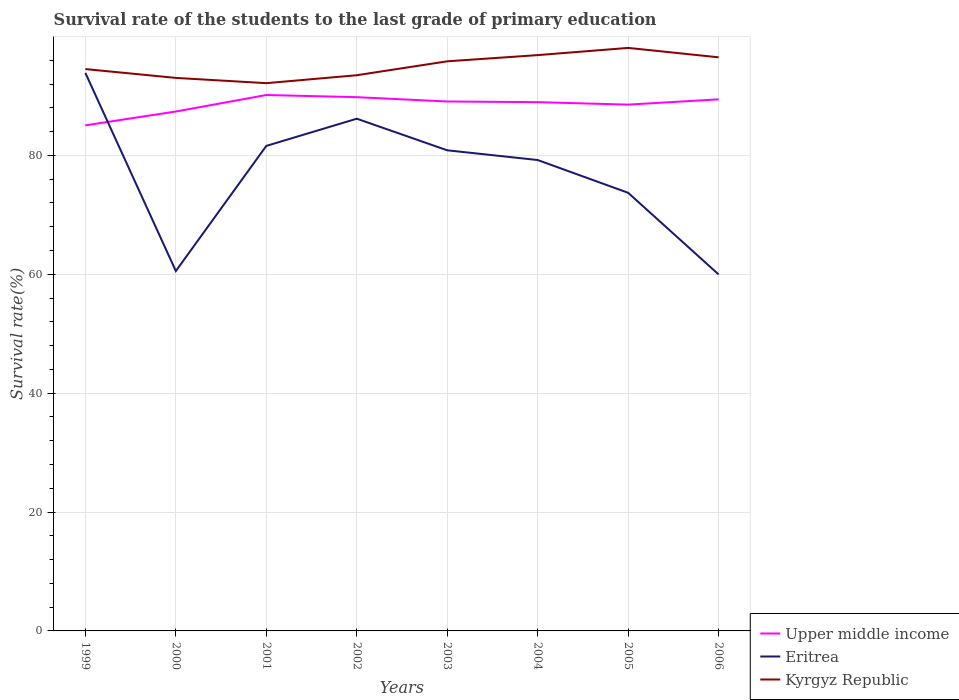How many different coloured lines are there?
Provide a short and direct response. 3. Does the line corresponding to Kyrgyz Republic intersect with the line corresponding to Eritrea?
Give a very brief answer. No. Across all years, what is the maximum survival rate of the students in Upper middle income?
Make the answer very short. 85.05. What is the total survival rate of the students in Upper middle income in the graph?
Keep it short and to the point. -2.78. What is the difference between the highest and the second highest survival rate of the students in Upper middle income?
Your answer should be compact. 5.1. What is the difference between the highest and the lowest survival rate of the students in Eritrea?
Make the answer very short. 5. How many lines are there?
Make the answer very short. 3. Does the graph contain grids?
Keep it short and to the point. Yes. Where does the legend appear in the graph?
Your response must be concise. Bottom right. What is the title of the graph?
Offer a very short reply. Survival rate of the students to the last grade of primary education. Does "China" appear as one of the legend labels in the graph?
Keep it short and to the point. No. What is the label or title of the X-axis?
Your response must be concise. Years. What is the label or title of the Y-axis?
Offer a terse response. Survival rate(%). What is the Survival rate(%) in Upper middle income in 1999?
Make the answer very short. 85.05. What is the Survival rate(%) of Eritrea in 1999?
Offer a terse response. 93.87. What is the Survival rate(%) in Kyrgyz Republic in 1999?
Keep it short and to the point. 94.52. What is the Survival rate(%) of Upper middle income in 2000?
Offer a very short reply. 87.38. What is the Survival rate(%) in Eritrea in 2000?
Keep it short and to the point. 60.54. What is the Survival rate(%) in Kyrgyz Republic in 2000?
Offer a terse response. 93.03. What is the Survival rate(%) of Upper middle income in 2001?
Your response must be concise. 90.16. What is the Survival rate(%) in Eritrea in 2001?
Provide a short and direct response. 81.59. What is the Survival rate(%) in Kyrgyz Republic in 2001?
Provide a succinct answer. 92.15. What is the Survival rate(%) in Upper middle income in 2002?
Offer a terse response. 89.79. What is the Survival rate(%) of Eritrea in 2002?
Your answer should be compact. 86.17. What is the Survival rate(%) of Kyrgyz Republic in 2002?
Offer a terse response. 93.48. What is the Survival rate(%) of Upper middle income in 2003?
Make the answer very short. 89.07. What is the Survival rate(%) of Eritrea in 2003?
Your answer should be very brief. 80.85. What is the Survival rate(%) in Kyrgyz Republic in 2003?
Offer a very short reply. 95.82. What is the Survival rate(%) of Upper middle income in 2004?
Your answer should be very brief. 88.95. What is the Survival rate(%) of Eritrea in 2004?
Provide a short and direct response. 79.22. What is the Survival rate(%) in Kyrgyz Republic in 2004?
Make the answer very short. 96.87. What is the Survival rate(%) of Upper middle income in 2005?
Keep it short and to the point. 88.54. What is the Survival rate(%) of Eritrea in 2005?
Keep it short and to the point. 73.7. What is the Survival rate(%) in Kyrgyz Republic in 2005?
Provide a short and direct response. 98.08. What is the Survival rate(%) of Upper middle income in 2006?
Your response must be concise. 89.43. What is the Survival rate(%) in Eritrea in 2006?
Provide a succinct answer. 59.97. What is the Survival rate(%) in Kyrgyz Republic in 2006?
Your response must be concise. 96.5. Across all years, what is the maximum Survival rate(%) of Upper middle income?
Provide a short and direct response. 90.16. Across all years, what is the maximum Survival rate(%) of Eritrea?
Make the answer very short. 93.87. Across all years, what is the maximum Survival rate(%) of Kyrgyz Republic?
Keep it short and to the point. 98.08. Across all years, what is the minimum Survival rate(%) of Upper middle income?
Make the answer very short. 85.05. Across all years, what is the minimum Survival rate(%) of Eritrea?
Offer a terse response. 59.97. Across all years, what is the minimum Survival rate(%) of Kyrgyz Republic?
Keep it short and to the point. 92.15. What is the total Survival rate(%) of Upper middle income in the graph?
Keep it short and to the point. 708.37. What is the total Survival rate(%) of Eritrea in the graph?
Make the answer very short. 615.93. What is the total Survival rate(%) of Kyrgyz Republic in the graph?
Keep it short and to the point. 760.45. What is the difference between the Survival rate(%) in Upper middle income in 1999 and that in 2000?
Offer a very short reply. -2.33. What is the difference between the Survival rate(%) of Eritrea in 1999 and that in 2000?
Your answer should be compact. 33.33. What is the difference between the Survival rate(%) in Kyrgyz Republic in 1999 and that in 2000?
Make the answer very short. 1.48. What is the difference between the Survival rate(%) of Upper middle income in 1999 and that in 2001?
Offer a terse response. -5.1. What is the difference between the Survival rate(%) in Eritrea in 1999 and that in 2001?
Your response must be concise. 12.28. What is the difference between the Survival rate(%) in Kyrgyz Republic in 1999 and that in 2001?
Offer a terse response. 2.37. What is the difference between the Survival rate(%) in Upper middle income in 1999 and that in 2002?
Give a very brief answer. -4.74. What is the difference between the Survival rate(%) of Eritrea in 1999 and that in 2002?
Offer a terse response. 7.7. What is the difference between the Survival rate(%) in Kyrgyz Republic in 1999 and that in 2002?
Provide a short and direct response. 1.03. What is the difference between the Survival rate(%) in Upper middle income in 1999 and that in 2003?
Your answer should be compact. -4.01. What is the difference between the Survival rate(%) in Eritrea in 1999 and that in 2003?
Your answer should be compact. 13.02. What is the difference between the Survival rate(%) in Kyrgyz Republic in 1999 and that in 2003?
Keep it short and to the point. -1.31. What is the difference between the Survival rate(%) in Upper middle income in 1999 and that in 2004?
Your answer should be very brief. -3.9. What is the difference between the Survival rate(%) in Eritrea in 1999 and that in 2004?
Provide a succinct answer. 14.66. What is the difference between the Survival rate(%) in Kyrgyz Republic in 1999 and that in 2004?
Your response must be concise. -2.35. What is the difference between the Survival rate(%) of Upper middle income in 1999 and that in 2005?
Give a very brief answer. -3.49. What is the difference between the Survival rate(%) of Eritrea in 1999 and that in 2005?
Your answer should be very brief. 20.17. What is the difference between the Survival rate(%) of Kyrgyz Republic in 1999 and that in 2005?
Keep it short and to the point. -3.56. What is the difference between the Survival rate(%) in Upper middle income in 1999 and that in 2006?
Provide a succinct answer. -4.37. What is the difference between the Survival rate(%) of Eritrea in 1999 and that in 2006?
Provide a short and direct response. 33.9. What is the difference between the Survival rate(%) in Kyrgyz Republic in 1999 and that in 2006?
Give a very brief answer. -1.98. What is the difference between the Survival rate(%) in Upper middle income in 2000 and that in 2001?
Your response must be concise. -2.78. What is the difference between the Survival rate(%) in Eritrea in 2000 and that in 2001?
Your answer should be compact. -21.05. What is the difference between the Survival rate(%) in Kyrgyz Republic in 2000 and that in 2001?
Your answer should be compact. 0.89. What is the difference between the Survival rate(%) of Upper middle income in 2000 and that in 2002?
Keep it short and to the point. -2.41. What is the difference between the Survival rate(%) in Eritrea in 2000 and that in 2002?
Your answer should be very brief. -25.63. What is the difference between the Survival rate(%) of Kyrgyz Republic in 2000 and that in 2002?
Your answer should be very brief. -0.45. What is the difference between the Survival rate(%) of Upper middle income in 2000 and that in 2003?
Make the answer very short. -1.69. What is the difference between the Survival rate(%) of Eritrea in 2000 and that in 2003?
Give a very brief answer. -20.31. What is the difference between the Survival rate(%) of Kyrgyz Republic in 2000 and that in 2003?
Offer a terse response. -2.79. What is the difference between the Survival rate(%) in Upper middle income in 2000 and that in 2004?
Offer a very short reply. -1.57. What is the difference between the Survival rate(%) in Eritrea in 2000 and that in 2004?
Provide a short and direct response. -18.67. What is the difference between the Survival rate(%) of Kyrgyz Republic in 2000 and that in 2004?
Keep it short and to the point. -3.83. What is the difference between the Survival rate(%) of Upper middle income in 2000 and that in 2005?
Offer a terse response. -1.16. What is the difference between the Survival rate(%) of Eritrea in 2000 and that in 2005?
Make the answer very short. -13.16. What is the difference between the Survival rate(%) of Kyrgyz Republic in 2000 and that in 2005?
Provide a short and direct response. -5.05. What is the difference between the Survival rate(%) of Upper middle income in 2000 and that in 2006?
Keep it short and to the point. -2.05. What is the difference between the Survival rate(%) in Eritrea in 2000 and that in 2006?
Keep it short and to the point. 0.57. What is the difference between the Survival rate(%) in Kyrgyz Republic in 2000 and that in 2006?
Give a very brief answer. -3.46. What is the difference between the Survival rate(%) in Upper middle income in 2001 and that in 2002?
Ensure brevity in your answer.  0.36. What is the difference between the Survival rate(%) of Eritrea in 2001 and that in 2002?
Offer a very short reply. -4.58. What is the difference between the Survival rate(%) in Kyrgyz Republic in 2001 and that in 2002?
Your response must be concise. -1.34. What is the difference between the Survival rate(%) in Upper middle income in 2001 and that in 2003?
Offer a very short reply. 1.09. What is the difference between the Survival rate(%) in Eritrea in 2001 and that in 2003?
Ensure brevity in your answer.  0.74. What is the difference between the Survival rate(%) in Kyrgyz Republic in 2001 and that in 2003?
Ensure brevity in your answer.  -3.68. What is the difference between the Survival rate(%) in Upper middle income in 2001 and that in 2004?
Ensure brevity in your answer.  1.2. What is the difference between the Survival rate(%) of Eritrea in 2001 and that in 2004?
Provide a succinct answer. 2.38. What is the difference between the Survival rate(%) in Kyrgyz Republic in 2001 and that in 2004?
Make the answer very short. -4.72. What is the difference between the Survival rate(%) of Upper middle income in 2001 and that in 2005?
Offer a very short reply. 1.62. What is the difference between the Survival rate(%) of Eritrea in 2001 and that in 2005?
Make the answer very short. 7.89. What is the difference between the Survival rate(%) of Kyrgyz Republic in 2001 and that in 2005?
Provide a succinct answer. -5.93. What is the difference between the Survival rate(%) of Upper middle income in 2001 and that in 2006?
Provide a succinct answer. 0.73. What is the difference between the Survival rate(%) in Eritrea in 2001 and that in 2006?
Your answer should be very brief. 21.62. What is the difference between the Survival rate(%) of Kyrgyz Republic in 2001 and that in 2006?
Offer a very short reply. -4.35. What is the difference between the Survival rate(%) of Upper middle income in 2002 and that in 2003?
Provide a succinct answer. 0.73. What is the difference between the Survival rate(%) of Eritrea in 2002 and that in 2003?
Ensure brevity in your answer.  5.32. What is the difference between the Survival rate(%) in Kyrgyz Republic in 2002 and that in 2003?
Your answer should be very brief. -2.34. What is the difference between the Survival rate(%) of Upper middle income in 2002 and that in 2004?
Your answer should be very brief. 0.84. What is the difference between the Survival rate(%) in Eritrea in 2002 and that in 2004?
Provide a succinct answer. 6.95. What is the difference between the Survival rate(%) of Kyrgyz Republic in 2002 and that in 2004?
Ensure brevity in your answer.  -3.38. What is the difference between the Survival rate(%) of Upper middle income in 2002 and that in 2005?
Provide a short and direct response. 1.25. What is the difference between the Survival rate(%) in Eritrea in 2002 and that in 2005?
Make the answer very short. 12.47. What is the difference between the Survival rate(%) in Kyrgyz Republic in 2002 and that in 2005?
Your answer should be very brief. -4.6. What is the difference between the Survival rate(%) in Upper middle income in 2002 and that in 2006?
Your answer should be very brief. 0.37. What is the difference between the Survival rate(%) of Eritrea in 2002 and that in 2006?
Make the answer very short. 26.2. What is the difference between the Survival rate(%) of Kyrgyz Republic in 2002 and that in 2006?
Your answer should be compact. -3.01. What is the difference between the Survival rate(%) of Upper middle income in 2003 and that in 2004?
Your answer should be very brief. 0.11. What is the difference between the Survival rate(%) of Eritrea in 2003 and that in 2004?
Provide a short and direct response. 1.64. What is the difference between the Survival rate(%) of Kyrgyz Republic in 2003 and that in 2004?
Your answer should be compact. -1.04. What is the difference between the Survival rate(%) in Upper middle income in 2003 and that in 2005?
Provide a succinct answer. 0.53. What is the difference between the Survival rate(%) of Eritrea in 2003 and that in 2005?
Your response must be concise. 7.15. What is the difference between the Survival rate(%) of Kyrgyz Republic in 2003 and that in 2005?
Offer a terse response. -2.26. What is the difference between the Survival rate(%) of Upper middle income in 2003 and that in 2006?
Offer a terse response. -0.36. What is the difference between the Survival rate(%) in Eritrea in 2003 and that in 2006?
Give a very brief answer. 20.88. What is the difference between the Survival rate(%) in Kyrgyz Republic in 2003 and that in 2006?
Keep it short and to the point. -0.67. What is the difference between the Survival rate(%) of Upper middle income in 2004 and that in 2005?
Make the answer very short. 0.41. What is the difference between the Survival rate(%) of Eritrea in 2004 and that in 2005?
Provide a succinct answer. 5.51. What is the difference between the Survival rate(%) of Kyrgyz Republic in 2004 and that in 2005?
Offer a terse response. -1.21. What is the difference between the Survival rate(%) of Upper middle income in 2004 and that in 2006?
Give a very brief answer. -0.47. What is the difference between the Survival rate(%) in Eritrea in 2004 and that in 2006?
Keep it short and to the point. 19.25. What is the difference between the Survival rate(%) of Kyrgyz Republic in 2004 and that in 2006?
Offer a terse response. 0.37. What is the difference between the Survival rate(%) of Upper middle income in 2005 and that in 2006?
Provide a short and direct response. -0.89. What is the difference between the Survival rate(%) in Eritrea in 2005 and that in 2006?
Give a very brief answer. 13.73. What is the difference between the Survival rate(%) of Kyrgyz Republic in 2005 and that in 2006?
Ensure brevity in your answer.  1.58. What is the difference between the Survival rate(%) in Upper middle income in 1999 and the Survival rate(%) in Eritrea in 2000?
Offer a terse response. 24.51. What is the difference between the Survival rate(%) of Upper middle income in 1999 and the Survival rate(%) of Kyrgyz Republic in 2000?
Give a very brief answer. -7.98. What is the difference between the Survival rate(%) in Eritrea in 1999 and the Survival rate(%) in Kyrgyz Republic in 2000?
Provide a short and direct response. 0.84. What is the difference between the Survival rate(%) of Upper middle income in 1999 and the Survival rate(%) of Eritrea in 2001?
Make the answer very short. 3.46. What is the difference between the Survival rate(%) of Upper middle income in 1999 and the Survival rate(%) of Kyrgyz Republic in 2001?
Give a very brief answer. -7.1. What is the difference between the Survival rate(%) in Eritrea in 1999 and the Survival rate(%) in Kyrgyz Republic in 2001?
Provide a succinct answer. 1.73. What is the difference between the Survival rate(%) of Upper middle income in 1999 and the Survival rate(%) of Eritrea in 2002?
Provide a short and direct response. -1.12. What is the difference between the Survival rate(%) of Upper middle income in 1999 and the Survival rate(%) of Kyrgyz Republic in 2002?
Provide a succinct answer. -8.43. What is the difference between the Survival rate(%) in Eritrea in 1999 and the Survival rate(%) in Kyrgyz Republic in 2002?
Provide a short and direct response. 0.39. What is the difference between the Survival rate(%) of Upper middle income in 1999 and the Survival rate(%) of Eritrea in 2003?
Offer a very short reply. 4.2. What is the difference between the Survival rate(%) in Upper middle income in 1999 and the Survival rate(%) in Kyrgyz Republic in 2003?
Keep it short and to the point. -10.77. What is the difference between the Survival rate(%) of Eritrea in 1999 and the Survival rate(%) of Kyrgyz Republic in 2003?
Your answer should be very brief. -1.95. What is the difference between the Survival rate(%) of Upper middle income in 1999 and the Survival rate(%) of Eritrea in 2004?
Your answer should be compact. 5.83. What is the difference between the Survival rate(%) in Upper middle income in 1999 and the Survival rate(%) in Kyrgyz Republic in 2004?
Provide a short and direct response. -11.81. What is the difference between the Survival rate(%) of Eritrea in 1999 and the Survival rate(%) of Kyrgyz Republic in 2004?
Ensure brevity in your answer.  -2.99. What is the difference between the Survival rate(%) in Upper middle income in 1999 and the Survival rate(%) in Eritrea in 2005?
Give a very brief answer. 11.35. What is the difference between the Survival rate(%) of Upper middle income in 1999 and the Survival rate(%) of Kyrgyz Republic in 2005?
Keep it short and to the point. -13.03. What is the difference between the Survival rate(%) in Eritrea in 1999 and the Survival rate(%) in Kyrgyz Republic in 2005?
Provide a short and direct response. -4.21. What is the difference between the Survival rate(%) of Upper middle income in 1999 and the Survival rate(%) of Eritrea in 2006?
Give a very brief answer. 25.08. What is the difference between the Survival rate(%) of Upper middle income in 1999 and the Survival rate(%) of Kyrgyz Republic in 2006?
Offer a very short reply. -11.44. What is the difference between the Survival rate(%) of Eritrea in 1999 and the Survival rate(%) of Kyrgyz Republic in 2006?
Your answer should be very brief. -2.62. What is the difference between the Survival rate(%) of Upper middle income in 2000 and the Survival rate(%) of Eritrea in 2001?
Your answer should be compact. 5.79. What is the difference between the Survival rate(%) in Upper middle income in 2000 and the Survival rate(%) in Kyrgyz Republic in 2001?
Your answer should be very brief. -4.77. What is the difference between the Survival rate(%) of Eritrea in 2000 and the Survival rate(%) of Kyrgyz Republic in 2001?
Your answer should be very brief. -31.6. What is the difference between the Survival rate(%) in Upper middle income in 2000 and the Survival rate(%) in Eritrea in 2002?
Your answer should be very brief. 1.21. What is the difference between the Survival rate(%) of Upper middle income in 2000 and the Survival rate(%) of Kyrgyz Republic in 2002?
Give a very brief answer. -6.1. What is the difference between the Survival rate(%) of Eritrea in 2000 and the Survival rate(%) of Kyrgyz Republic in 2002?
Provide a short and direct response. -32.94. What is the difference between the Survival rate(%) of Upper middle income in 2000 and the Survival rate(%) of Eritrea in 2003?
Your answer should be compact. 6.53. What is the difference between the Survival rate(%) in Upper middle income in 2000 and the Survival rate(%) in Kyrgyz Republic in 2003?
Offer a very short reply. -8.45. What is the difference between the Survival rate(%) in Eritrea in 2000 and the Survival rate(%) in Kyrgyz Republic in 2003?
Make the answer very short. -35.28. What is the difference between the Survival rate(%) in Upper middle income in 2000 and the Survival rate(%) in Eritrea in 2004?
Make the answer very short. 8.16. What is the difference between the Survival rate(%) in Upper middle income in 2000 and the Survival rate(%) in Kyrgyz Republic in 2004?
Provide a short and direct response. -9.49. What is the difference between the Survival rate(%) of Eritrea in 2000 and the Survival rate(%) of Kyrgyz Republic in 2004?
Offer a terse response. -36.32. What is the difference between the Survival rate(%) in Upper middle income in 2000 and the Survival rate(%) in Eritrea in 2005?
Give a very brief answer. 13.68. What is the difference between the Survival rate(%) of Upper middle income in 2000 and the Survival rate(%) of Kyrgyz Republic in 2005?
Make the answer very short. -10.7. What is the difference between the Survival rate(%) in Eritrea in 2000 and the Survival rate(%) in Kyrgyz Republic in 2005?
Your answer should be very brief. -37.54. What is the difference between the Survival rate(%) in Upper middle income in 2000 and the Survival rate(%) in Eritrea in 2006?
Offer a very short reply. 27.41. What is the difference between the Survival rate(%) of Upper middle income in 2000 and the Survival rate(%) of Kyrgyz Republic in 2006?
Provide a short and direct response. -9.12. What is the difference between the Survival rate(%) of Eritrea in 2000 and the Survival rate(%) of Kyrgyz Republic in 2006?
Give a very brief answer. -35.95. What is the difference between the Survival rate(%) of Upper middle income in 2001 and the Survival rate(%) of Eritrea in 2002?
Keep it short and to the point. 3.99. What is the difference between the Survival rate(%) in Upper middle income in 2001 and the Survival rate(%) in Kyrgyz Republic in 2002?
Your answer should be compact. -3.33. What is the difference between the Survival rate(%) in Eritrea in 2001 and the Survival rate(%) in Kyrgyz Republic in 2002?
Give a very brief answer. -11.89. What is the difference between the Survival rate(%) in Upper middle income in 2001 and the Survival rate(%) in Eritrea in 2003?
Your answer should be compact. 9.3. What is the difference between the Survival rate(%) of Upper middle income in 2001 and the Survival rate(%) of Kyrgyz Republic in 2003?
Ensure brevity in your answer.  -5.67. What is the difference between the Survival rate(%) in Eritrea in 2001 and the Survival rate(%) in Kyrgyz Republic in 2003?
Ensure brevity in your answer.  -14.23. What is the difference between the Survival rate(%) of Upper middle income in 2001 and the Survival rate(%) of Eritrea in 2004?
Provide a short and direct response. 10.94. What is the difference between the Survival rate(%) of Upper middle income in 2001 and the Survival rate(%) of Kyrgyz Republic in 2004?
Offer a terse response. -6.71. What is the difference between the Survival rate(%) of Eritrea in 2001 and the Survival rate(%) of Kyrgyz Republic in 2004?
Make the answer very short. -15.27. What is the difference between the Survival rate(%) of Upper middle income in 2001 and the Survival rate(%) of Eritrea in 2005?
Your answer should be very brief. 16.45. What is the difference between the Survival rate(%) in Upper middle income in 2001 and the Survival rate(%) in Kyrgyz Republic in 2005?
Your answer should be compact. -7.92. What is the difference between the Survival rate(%) in Eritrea in 2001 and the Survival rate(%) in Kyrgyz Republic in 2005?
Your response must be concise. -16.49. What is the difference between the Survival rate(%) in Upper middle income in 2001 and the Survival rate(%) in Eritrea in 2006?
Your answer should be very brief. 30.19. What is the difference between the Survival rate(%) in Upper middle income in 2001 and the Survival rate(%) in Kyrgyz Republic in 2006?
Provide a short and direct response. -6.34. What is the difference between the Survival rate(%) of Eritrea in 2001 and the Survival rate(%) of Kyrgyz Republic in 2006?
Ensure brevity in your answer.  -14.9. What is the difference between the Survival rate(%) in Upper middle income in 2002 and the Survival rate(%) in Eritrea in 2003?
Offer a very short reply. 8.94. What is the difference between the Survival rate(%) of Upper middle income in 2002 and the Survival rate(%) of Kyrgyz Republic in 2003?
Your answer should be very brief. -6.03. What is the difference between the Survival rate(%) in Eritrea in 2002 and the Survival rate(%) in Kyrgyz Republic in 2003?
Make the answer very short. -9.65. What is the difference between the Survival rate(%) of Upper middle income in 2002 and the Survival rate(%) of Eritrea in 2004?
Your answer should be compact. 10.57. What is the difference between the Survival rate(%) in Upper middle income in 2002 and the Survival rate(%) in Kyrgyz Republic in 2004?
Your answer should be very brief. -7.07. What is the difference between the Survival rate(%) in Eritrea in 2002 and the Survival rate(%) in Kyrgyz Republic in 2004?
Ensure brevity in your answer.  -10.7. What is the difference between the Survival rate(%) of Upper middle income in 2002 and the Survival rate(%) of Eritrea in 2005?
Ensure brevity in your answer.  16.09. What is the difference between the Survival rate(%) of Upper middle income in 2002 and the Survival rate(%) of Kyrgyz Republic in 2005?
Offer a terse response. -8.29. What is the difference between the Survival rate(%) of Eritrea in 2002 and the Survival rate(%) of Kyrgyz Republic in 2005?
Offer a very short reply. -11.91. What is the difference between the Survival rate(%) in Upper middle income in 2002 and the Survival rate(%) in Eritrea in 2006?
Provide a succinct answer. 29.82. What is the difference between the Survival rate(%) of Upper middle income in 2002 and the Survival rate(%) of Kyrgyz Republic in 2006?
Give a very brief answer. -6.7. What is the difference between the Survival rate(%) of Eritrea in 2002 and the Survival rate(%) of Kyrgyz Republic in 2006?
Your answer should be compact. -10.33. What is the difference between the Survival rate(%) of Upper middle income in 2003 and the Survival rate(%) of Eritrea in 2004?
Provide a short and direct response. 9.85. What is the difference between the Survival rate(%) of Upper middle income in 2003 and the Survival rate(%) of Kyrgyz Republic in 2004?
Your response must be concise. -7.8. What is the difference between the Survival rate(%) in Eritrea in 2003 and the Survival rate(%) in Kyrgyz Republic in 2004?
Offer a terse response. -16.01. What is the difference between the Survival rate(%) of Upper middle income in 2003 and the Survival rate(%) of Eritrea in 2005?
Provide a short and direct response. 15.36. What is the difference between the Survival rate(%) in Upper middle income in 2003 and the Survival rate(%) in Kyrgyz Republic in 2005?
Give a very brief answer. -9.01. What is the difference between the Survival rate(%) of Eritrea in 2003 and the Survival rate(%) of Kyrgyz Republic in 2005?
Your answer should be very brief. -17.23. What is the difference between the Survival rate(%) in Upper middle income in 2003 and the Survival rate(%) in Eritrea in 2006?
Offer a very short reply. 29.1. What is the difference between the Survival rate(%) in Upper middle income in 2003 and the Survival rate(%) in Kyrgyz Republic in 2006?
Offer a terse response. -7.43. What is the difference between the Survival rate(%) of Eritrea in 2003 and the Survival rate(%) of Kyrgyz Republic in 2006?
Your answer should be very brief. -15.64. What is the difference between the Survival rate(%) in Upper middle income in 2004 and the Survival rate(%) in Eritrea in 2005?
Keep it short and to the point. 15.25. What is the difference between the Survival rate(%) in Upper middle income in 2004 and the Survival rate(%) in Kyrgyz Republic in 2005?
Offer a very short reply. -9.13. What is the difference between the Survival rate(%) of Eritrea in 2004 and the Survival rate(%) of Kyrgyz Republic in 2005?
Your answer should be very brief. -18.86. What is the difference between the Survival rate(%) in Upper middle income in 2004 and the Survival rate(%) in Eritrea in 2006?
Provide a short and direct response. 28.98. What is the difference between the Survival rate(%) of Upper middle income in 2004 and the Survival rate(%) of Kyrgyz Republic in 2006?
Your response must be concise. -7.54. What is the difference between the Survival rate(%) of Eritrea in 2004 and the Survival rate(%) of Kyrgyz Republic in 2006?
Offer a terse response. -17.28. What is the difference between the Survival rate(%) in Upper middle income in 2005 and the Survival rate(%) in Eritrea in 2006?
Ensure brevity in your answer.  28.57. What is the difference between the Survival rate(%) in Upper middle income in 2005 and the Survival rate(%) in Kyrgyz Republic in 2006?
Give a very brief answer. -7.96. What is the difference between the Survival rate(%) in Eritrea in 2005 and the Survival rate(%) in Kyrgyz Republic in 2006?
Make the answer very short. -22.79. What is the average Survival rate(%) of Upper middle income per year?
Provide a short and direct response. 88.55. What is the average Survival rate(%) in Eritrea per year?
Give a very brief answer. 76.99. What is the average Survival rate(%) of Kyrgyz Republic per year?
Keep it short and to the point. 95.06. In the year 1999, what is the difference between the Survival rate(%) of Upper middle income and Survival rate(%) of Eritrea?
Keep it short and to the point. -8.82. In the year 1999, what is the difference between the Survival rate(%) of Upper middle income and Survival rate(%) of Kyrgyz Republic?
Your answer should be compact. -9.47. In the year 1999, what is the difference between the Survival rate(%) in Eritrea and Survival rate(%) in Kyrgyz Republic?
Ensure brevity in your answer.  -0.64. In the year 2000, what is the difference between the Survival rate(%) in Upper middle income and Survival rate(%) in Eritrea?
Your answer should be compact. 26.84. In the year 2000, what is the difference between the Survival rate(%) of Upper middle income and Survival rate(%) of Kyrgyz Republic?
Ensure brevity in your answer.  -5.65. In the year 2000, what is the difference between the Survival rate(%) in Eritrea and Survival rate(%) in Kyrgyz Republic?
Give a very brief answer. -32.49. In the year 2001, what is the difference between the Survival rate(%) of Upper middle income and Survival rate(%) of Eritrea?
Your answer should be very brief. 8.56. In the year 2001, what is the difference between the Survival rate(%) in Upper middle income and Survival rate(%) in Kyrgyz Republic?
Give a very brief answer. -1.99. In the year 2001, what is the difference between the Survival rate(%) in Eritrea and Survival rate(%) in Kyrgyz Republic?
Provide a succinct answer. -10.55. In the year 2002, what is the difference between the Survival rate(%) of Upper middle income and Survival rate(%) of Eritrea?
Provide a short and direct response. 3.62. In the year 2002, what is the difference between the Survival rate(%) in Upper middle income and Survival rate(%) in Kyrgyz Republic?
Your answer should be very brief. -3.69. In the year 2002, what is the difference between the Survival rate(%) of Eritrea and Survival rate(%) of Kyrgyz Republic?
Offer a very short reply. -7.31. In the year 2003, what is the difference between the Survival rate(%) in Upper middle income and Survival rate(%) in Eritrea?
Provide a succinct answer. 8.21. In the year 2003, what is the difference between the Survival rate(%) in Upper middle income and Survival rate(%) in Kyrgyz Republic?
Provide a short and direct response. -6.76. In the year 2003, what is the difference between the Survival rate(%) of Eritrea and Survival rate(%) of Kyrgyz Republic?
Give a very brief answer. -14.97. In the year 2004, what is the difference between the Survival rate(%) in Upper middle income and Survival rate(%) in Eritrea?
Offer a very short reply. 9.74. In the year 2004, what is the difference between the Survival rate(%) of Upper middle income and Survival rate(%) of Kyrgyz Republic?
Offer a terse response. -7.91. In the year 2004, what is the difference between the Survival rate(%) in Eritrea and Survival rate(%) in Kyrgyz Republic?
Your response must be concise. -17.65. In the year 2005, what is the difference between the Survival rate(%) of Upper middle income and Survival rate(%) of Eritrea?
Offer a very short reply. 14.84. In the year 2005, what is the difference between the Survival rate(%) in Upper middle income and Survival rate(%) in Kyrgyz Republic?
Your response must be concise. -9.54. In the year 2005, what is the difference between the Survival rate(%) of Eritrea and Survival rate(%) of Kyrgyz Republic?
Provide a succinct answer. -24.38. In the year 2006, what is the difference between the Survival rate(%) of Upper middle income and Survival rate(%) of Eritrea?
Provide a short and direct response. 29.46. In the year 2006, what is the difference between the Survival rate(%) of Upper middle income and Survival rate(%) of Kyrgyz Republic?
Your answer should be very brief. -7.07. In the year 2006, what is the difference between the Survival rate(%) of Eritrea and Survival rate(%) of Kyrgyz Republic?
Give a very brief answer. -36.53. What is the ratio of the Survival rate(%) in Upper middle income in 1999 to that in 2000?
Offer a terse response. 0.97. What is the ratio of the Survival rate(%) in Eritrea in 1999 to that in 2000?
Offer a terse response. 1.55. What is the ratio of the Survival rate(%) of Kyrgyz Republic in 1999 to that in 2000?
Make the answer very short. 1.02. What is the ratio of the Survival rate(%) in Upper middle income in 1999 to that in 2001?
Your response must be concise. 0.94. What is the ratio of the Survival rate(%) of Eritrea in 1999 to that in 2001?
Your answer should be very brief. 1.15. What is the ratio of the Survival rate(%) of Kyrgyz Republic in 1999 to that in 2001?
Offer a terse response. 1.03. What is the ratio of the Survival rate(%) in Upper middle income in 1999 to that in 2002?
Offer a very short reply. 0.95. What is the ratio of the Survival rate(%) of Eritrea in 1999 to that in 2002?
Provide a short and direct response. 1.09. What is the ratio of the Survival rate(%) in Kyrgyz Republic in 1999 to that in 2002?
Ensure brevity in your answer.  1.01. What is the ratio of the Survival rate(%) in Upper middle income in 1999 to that in 2003?
Ensure brevity in your answer.  0.95. What is the ratio of the Survival rate(%) of Eritrea in 1999 to that in 2003?
Your answer should be very brief. 1.16. What is the ratio of the Survival rate(%) of Kyrgyz Republic in 1999 to that in 2003?
Offer a terse response. 0.99. What is the ratio of the Survival rate(%) of Upper middle income in 1999 to that in 2004?
Offer a very short reply. 0.96. What is the ratio of the Survival rate(%) in Eritrea in 1999 to that in 2004?
Offer a very short reply. 1.19. What is the ratio of the Survival rate(%) in Kyrgyz Republic in 1999 to that in 2004?
Give a very brief answer. 0.98. What is the ratio of the Survival rate(%) of Upper middle income in 1999 to that in 2005?
Give a very brief answer. 0.96. What is the ratio of the Survival rate(%) in Eritrea in 1999 to that in 2005?
Offer a very short reply. 1.27. What is the ratio of the Survival rate(%) of Kyrgyz Republic in 1999 to that in 2005?
Offer a terse response. 0.96. What is the ratio of the Survival rate(%) of Upper middle income in 1999 to that in 2006?
Your answer should be compact. 0.95. What is the ratio of the Survival rate(%) of Eritrea in 1999 to that in 2006?
Your answer should be compact. 1.57. What is the ratio of the Survival rate(%) in Kyrgyz Republic in 1999 to that in 2006?
Your response must be concise. 0.98. What is the ratio of the Survival rate(%) of Upper middle income in 2000 to that in 2001?
Give a very brief answer. 0.97. What is the ratio of the Survival rate(%) in Eritrea in 2000 to that in 2001?
Make the answer very short. 0.74. What is the ratio of the Survival rate(%) in Kyrgyz Republic in 2000 to that in 2001?
Keep it short and to the point. 1.01. What is the ratio of the Survival rate(%) in Upper middle income in 2000 to that in 2002?
Your answer should be compact. 0.97. What is the ratio of the Survival rate(%) in Eritrea in 2000 to that in 2002?
Offer a very short reply. 0.7. What is the ratio of the Survival rate(%) in Upper middle income in 2000 to that in 2003?
Keep it short and to the point. 0.98. What is the ratio of the Survival rate(%) of Eritrea in 2000 to that in 2003?
Make the answer very short. 0.75. What is the ratio of the Survival rate(%) of Kyrgyz Republic in 2000 to that in 2003?
Your answer should be very brief. 0.97. What is the ratio of the Survival rate(%) in Upper middle income in 2000 to that in 2004?
Provide a succinct answer. 0.98. What is the ratio of the Survival rate(%) in Eritrea in 2000 to that in 2004?
Keep it short and to the point. 0.76. What is the ratio of the Survival rate(%) in Kyrgyz Republic in 2000 to that in 2004?
Offer a very short reply. 0.96. What is the ratio of the Survival rate(%) of Upper middle income in 2000 to that in 2005?
Offer a very short reply. 0.99. What is the ratio of the Survival rate(%) in Eritrea in 2000 to that in 2005?
Make the answer very short. 0.82. What is the ratio of the Survival rate(%) in Kyrgyz Republic in 2000 to that in 2005?
Offer a terse response. 0.95. What is the ratio of the Survival rate(%) in Upper middle income in 2000 to that in 2006?
Your answer should be very brief. 0.98. What is the ratio of the Survival rate(%) in Eritrea in 2000 to that in 2006?
Provide a succinct answer. 1.01. What is the ratio of the Survival rate(%) of Kyrgyz Republic in 2000 to that in 2006?
Your answer should be very brief. 0.96. What is the ratio of the Survival rate(%) in Upper middle income in 2001 to that in 2002?
Offer a very short reply. 1. What is the ratio of the Survival rate(%) in Eritrea in 2001 to that in 2002?
Provide a short and direct response. 0.95. What is the ratio of the Survival rate(%) of Kyrgyz Republic in 2001 to that in 2002?
Your answer should be very brief. 0.99. What is the ratio of the Survival rate(%) of Upper middle income in 2001 to that in 2003?
Make the answer very short. 1.01. What is the ratio of the Survival rate(%) in Eritrea in 2001 to that in 2003?
Ensure brevity in your answer.  1.01. What is the ratio of the Survival rate(%) in Kyrgyz Republic in 2001 to that in 2003?
Provide a short and direct response. 0.96. What is the ratio of the Survival rate(%) of Upper middle income in 2001 to that in 2004?
Make the answer very short. 1.01. What is the ratio of the Survival rate(%) of Eritrea in 2001 to that in 2004?
Your response must be concise. 1.03. What is the ratio of the Survival rate(%) in Kyrgyz Republic in 2001 to that in 2004?
Ensure brevity in your answer.  0.95. What is the ratio of the Survival rate(%) in Upper middle income in 2001 to that in 2005?
Provide a succinct answer. 1.02. What is the ratio of the Survival rate(%) in Eritrea in 2001 to that in 2005?
Your answer should be very brief. 1.11. What is the ratio of the Survival rate(%) of Kyrgyz Republic in 2001 to that in 2005?
Provide a succinct answer. 0.94. What is the ratio of the Survival rate(%) in Upper middle income in 2001 to that in 2006?
Provide a short and direct response. 1.01. What is the ratio of the Survival rate(%) of Eritrea in 2001 to that in 2006?
Provide a short and direct response. 1.36. What is the ratio of the Survival rate(%) in Kyrgyz Republic in 2001 to that in 2006?
Give a very brief answer. 0.95. What is the ratio of the Survival rate(%) of Upper middle income in 2002 to that in 2003?
Your response must be concise. 1.01. What is the ratio of the Survival rate(%) in Eritrea in 2002 to that in 2003?
Provide a succinct answer. 1.07. What is the ratio of the Survival rate(%) of Kyrgyz Republic in 2002 to that in 2003?
Give a very brief answer. 0.98. What is the ratio of the Survival rate(%) of Upper middle income in 2002 to that in 2004?
Your answer should be compact. 1.01. What is the ratio of the Survival rate(%) of Eritrea in 2002 to that in 2004?
Your answer should be compact. 1.09. What is the ratio of the Survival rate(%) in Kyrgyz Republic in 2002 to that in 2004?
Ensure brevity in your answer.  0.97. What is the ratio of the Survival rate(%) of Upper middle income in 2002 to that in 2005?
Provide a short and direct response. 1.01. What is the ratio of the Survival rate(%) of Eritrea in 2002 to that in 2005?
Offer a very short reply. 1.17. What is the ratio of the Survival rate(%) of Kyrgyz Republic in 2002 to that in 2005?
Your response must be concise. 0.95. What is the ratio of the Survival rate(%) of Upper middle income in 2002 to that in 2006?
Give a very brief answer. 1. What is the ratio of the Survival rate(%) in Eritrea in 2002 to that in 2006?
Offer a terse response. 1.44. What is the ratio of the Survival rate(%) in Kyrgyz Republic in 2002 to that in 2006?
Ensure brevity in your answer.  0.97. What is the ratio of the Survival rate(%) of Eritrea in 2003 to that in 2004?
Your answer should be very brief. 1.02. What is the ratio of the Survival rate(%) of Kyrgyz Republic in 2003 to that in 2004?
Give a very brief answer. 0.99. What is the ratio of the Survival rate(%) in Upper middle income in 2003 to that in 2005?
Provide a short and direct response. 1.01. What is the ratio of the Survival rate(%) of Eritrea in 2003 to that in 2005?
Ensure brevity in your answer.  1.1. What is the ratio of the Survival rate(%) of Kyrgyz Republic in 2003 to that in 2005?
Give a very brief answer. 0.98. What is the ratio of the Survival rate(%) of Upper middle income in 2003 to that in 2006?
Make the answer very short. 1. What is the ratio of the Survival rate(%) in Eritrea in 2003 to that in 2006?
Provide a succinct answer. 1.35. What is the ratio of the Survival rate(%) of Eritrea in 2004 to that in 2005?
Make the answer very short. 1.07. What is the ratio of the Survival rate(%) in Kyrgyz Republic in 2004 to that in 2005?
Make the answer very short. 0.99. What is the ratio of the Survival rate(%) in Upper middle income in 2004 to that in 2006?
Keep it short and to the point. 0.99. What is the ratio of the Survival rate(%) in Eritrea in 2004 to that in 2006?
Keep it short and to the point. 1.32. What is the ratio of the Survival rate(%) in Upper middle income in 2005 to that in 2006?
Give a very brief answer. 0.99. What is the ratio of the Survival rate(%) of Eritrea in 2005 to that in 2006?
Make the answer very short. 1.23. What is the ratio of the Survival rate(%) in Kyrgyz Republic in 2005 to that in 2006?
Provide a succinct answer. 1.02. What is the difference between the highest and the second highest Survival rate(%) in Upper middle income?
Your response must be concise. 0.36. What is the difference between the highest and the second highest Survival rate(%) in Eritrea?
Provide a short and direct response. 7.7. What is the difference between the highest and the second highest Survival rate(%) of Kyrgyz Republic?
Offer a very short reply. 1.21. What is the difference between the highest and the lowest Survival rate(%) in Upper middle income?
Ensure brevity in your answer.  5.1. What is the difference between the highest and the lowest Survival rate(%) in Eritrea?
Provide a short and direct response. 33.9. What is the difference between the highest and the lowest Survival rate(%) in Kyrgyz Republic?
Give a very brief answer. 5.93. 